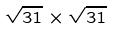<formula> <loc_0><loc_0><loc_500><loc_500>\sqrt { 3 1 } \times \sqrt { 3 1 }</formula> 